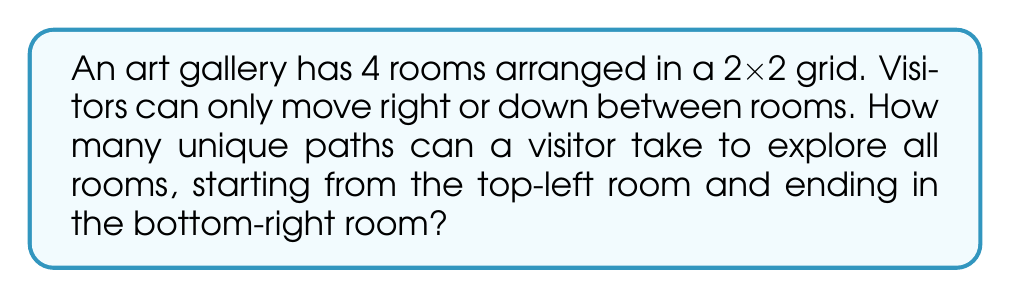Can you answer this question? Let's approach this step-by-step:

1) First, visualize the gallery layout:

   [asy]
   unitsize(1cm);
   draw((0,0)--(2,0)--(2,2)--(0,2)--cycle);
   draw((1,0)--(1,2));
   draw((0,1)--(2,1));
   label("Start", (0.5,1.5));
   label("End", (1.5,0.5));
   [/asy]

2) To reach the end from the start, the visitor must move right twice and down twice. The order of these moves determines the path.

3) This is equivalent to choosing which 2 out of the 4 total moves will be "right" moves (or equivalently, which 2 will be "down" moves).

4) This is a combination problem. We can use the formula:

   $$C(n,r) = \frac{n!}{r!(n-r)!}$$

   Where $n$ is the total number of moves (4) and $r$ is the number of right moves (2).

5) Plugging in the numbers:

   $$C(4,2) = \frac{4!}{2!(4-2)!} = \frac{4!}{2!2!}$$

6) Expand this:
   
   $$\frac{4 \times 3 \times 2 \times 1}{(2 \times 1)(2 \times 1)} = \frac{24}{4} = 6$$

Therefore, there are 6 unique paths through the gallery.
Answer: 6 